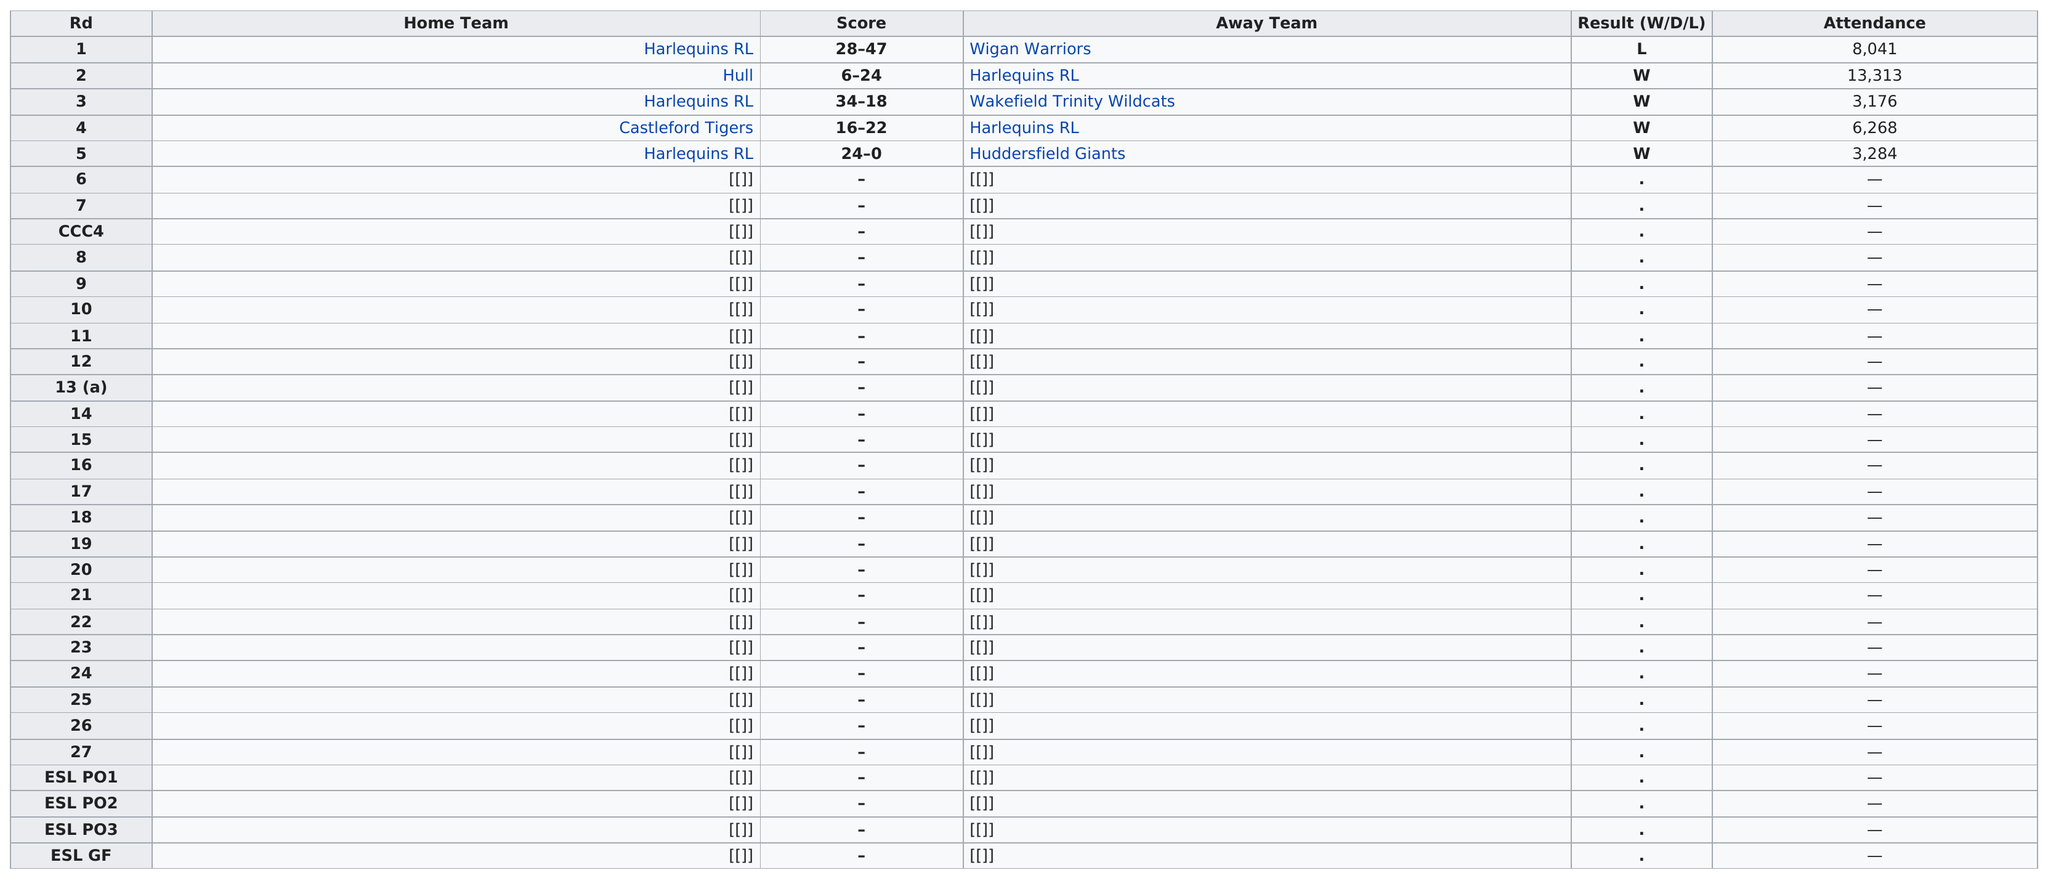Indicate a few pertinent items in this graphic. The Harlequins Rugby League team played against Hull in a game that was attended by 13,313 people. The Harlequins RL scored the most points among the home team. Wigan Warriors were the first team to win the first round. 